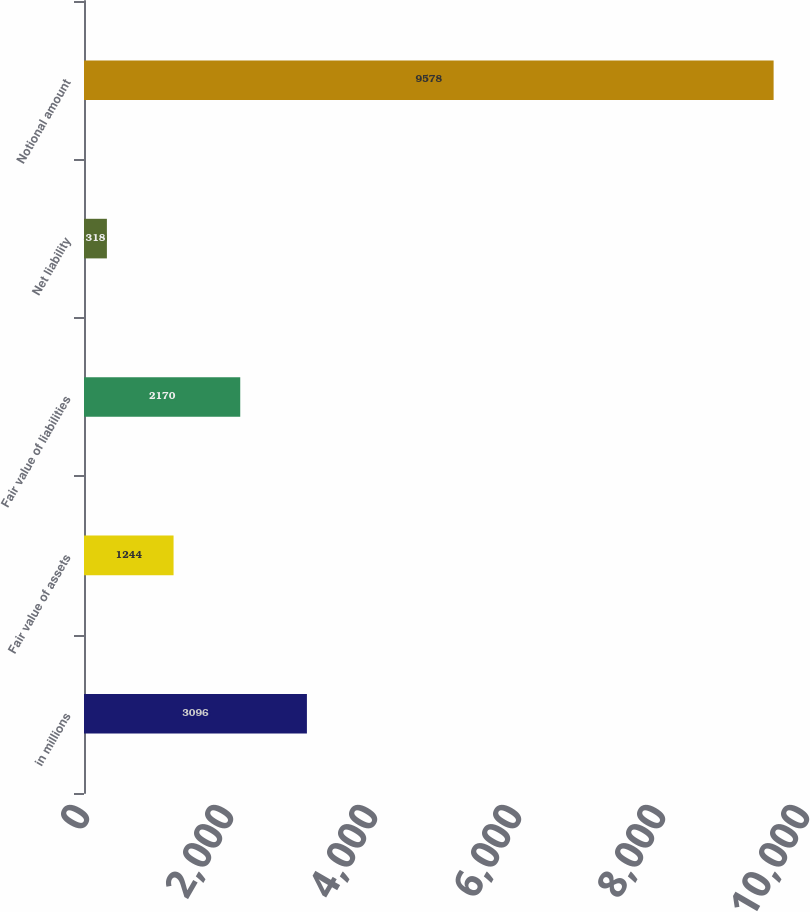Convert chart to OTSL. <chart><loc_0><loc_0><loc_500><loc_500><bar_chart><fcel>in millions<fcel>Fair value of assets<fcel>Fair value of liabilities<fcel>Net liability<fcel>Notional amount<nl><fcel>3096<fcel>1244<fcel>2170<fcel>318<fcel>9578<nl></chart> 